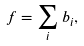Convert formula to latex. <formula><loc_0><loc_0><loc_500><loc_500>f = \sum _ { i } b _ { i } ,</formula> 